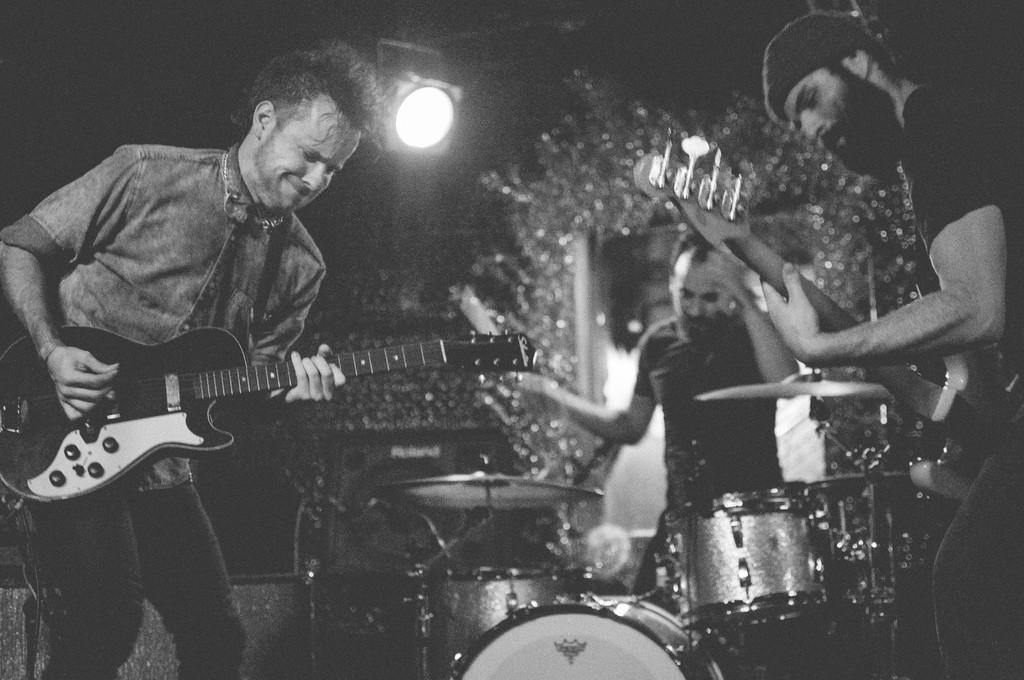What is the color scheme of the image? The image is black and white. What are the people in the image doing? The people are playing musical instruments in the image. What can be seen at the top of the image? There are focusing lights visible at the top of the image. Can you tell me how many goldfish are swimming in the building in the image? There are no goldfish or buildings present in the image; it features people playing musical instruments and focusing lights. 